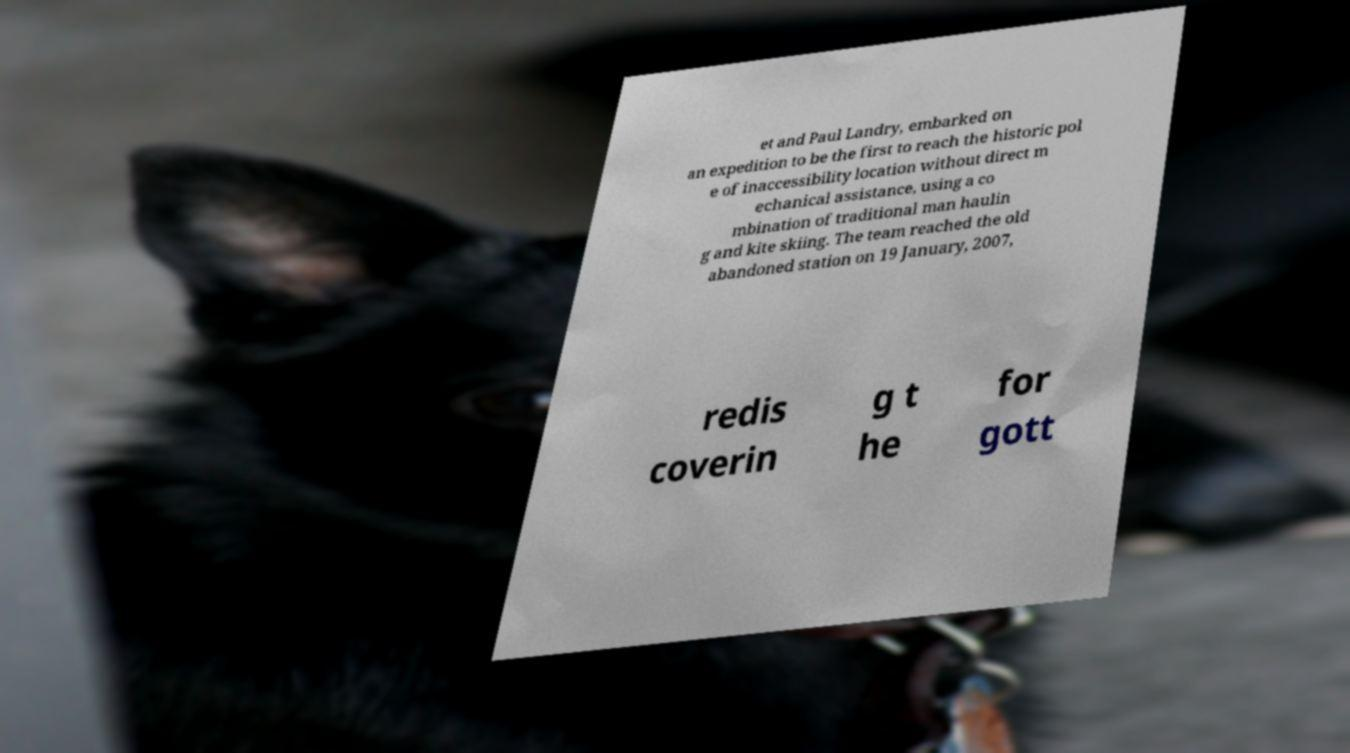Could you assist in decoding the text presented in this image and type it out clearly? et and Paul Landry, embarked on an expedition to be the first to reach the historic pol e of inaccessibility location without direct m echanical assistance, using a co mbination of traditional man haulin g and kite skiing. The team reached the old abandoned station on 19 January, 2007, redis coverin g t he for gott 